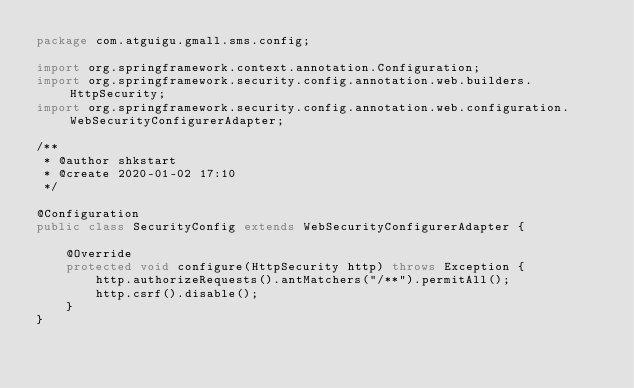Convert code to text. <code><loc_0><loc_0><loc_500><loc_500><_Java_>package com.atguigu.gmall.sms.config;

import org.springframework.context.annotation.Configuration;
import org.springframework.security.config.annotation.web.builders.HttpSecurity;
import org.springframework.security.config.annotation.web.configuration.WebSecurityConfigurerAdapter;

/**
 * @author shkstart
 * @create 2020-01-02 17:10
 */

@Configuration
public class SecurityConfig extends WebSecurityConfigurerAdapter {

    @Override
    protected void configure(HttpSecurity http) throws Exception {
        http.authorizeRequests().antMatchers("/**").permitAll();
        http.csrf().disable();
    }
}
</code> 